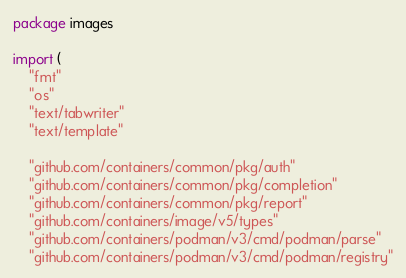<code> <loc_0><loc_0><loc_500><loc_500><_Go_>package images

import (
	"fmt"
	"os"
	"text/tabwriter"
	"text/template"

	"github.com/containers/common/pkg/auth"
	"github.com/containers/common/pkg/completion"
	"github.com/containers/common/pkg/report"
	"github.com/containers/image/v5/types"
	"github.com/containers/podman/v3/cmd/podman/parse"
	"github.com/containers/podman/v3/cmd/podman/registry"</code> 